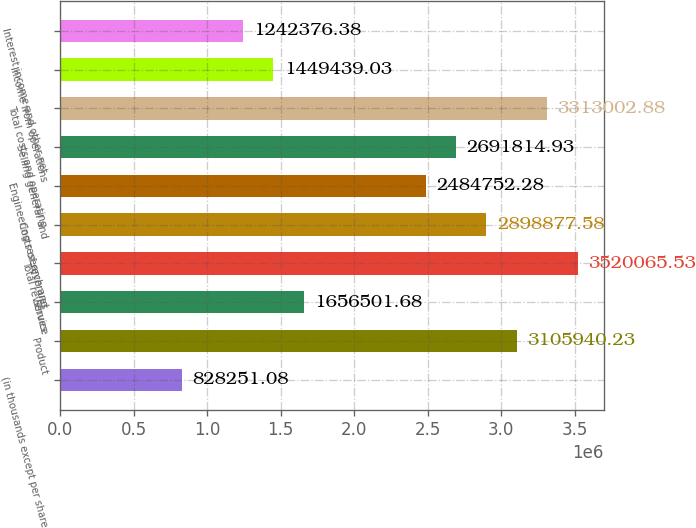Convert chart to OTSL. <chart><loc_0><loc_0><loc_500><loc_500><bar_chart><fcel>(in thousands except per share<fcel>Product<fcel>Service<fcel>Total revenues<fcel>Costs of revenues<fcel>Engineering research and<fcel>Selling general and<fcel>Total costs and operating<fcel>Income from operations<fcel>Interest income and other net<nl><fcel>828251<fcel>3.10594e+06<fcel>1.6565e+06<fcel>3.52007e+06<fcel>2.89888e+06<fcel>2.48475e+06<fcel>2.69181e+06<fcel>3.313e+06<fcel>1.44944e+06<fcel>1.24238e+06<nl></chart> 